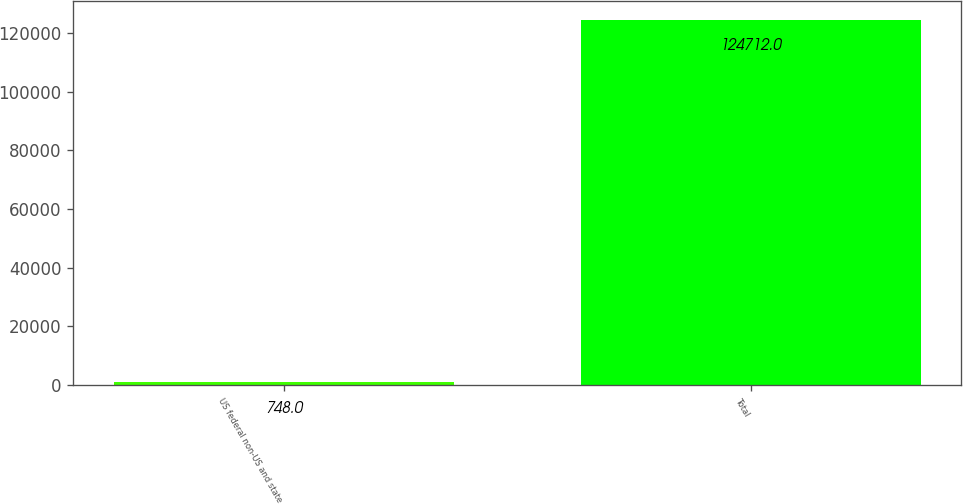Convert chart to OTSL. <chart><loc_0><loc_0><loc_500><loc_500><bar_chart><fcel>US federal non-US and state<fcel>Total<nl><fcel>748<fcel>124712<nl></chart> 